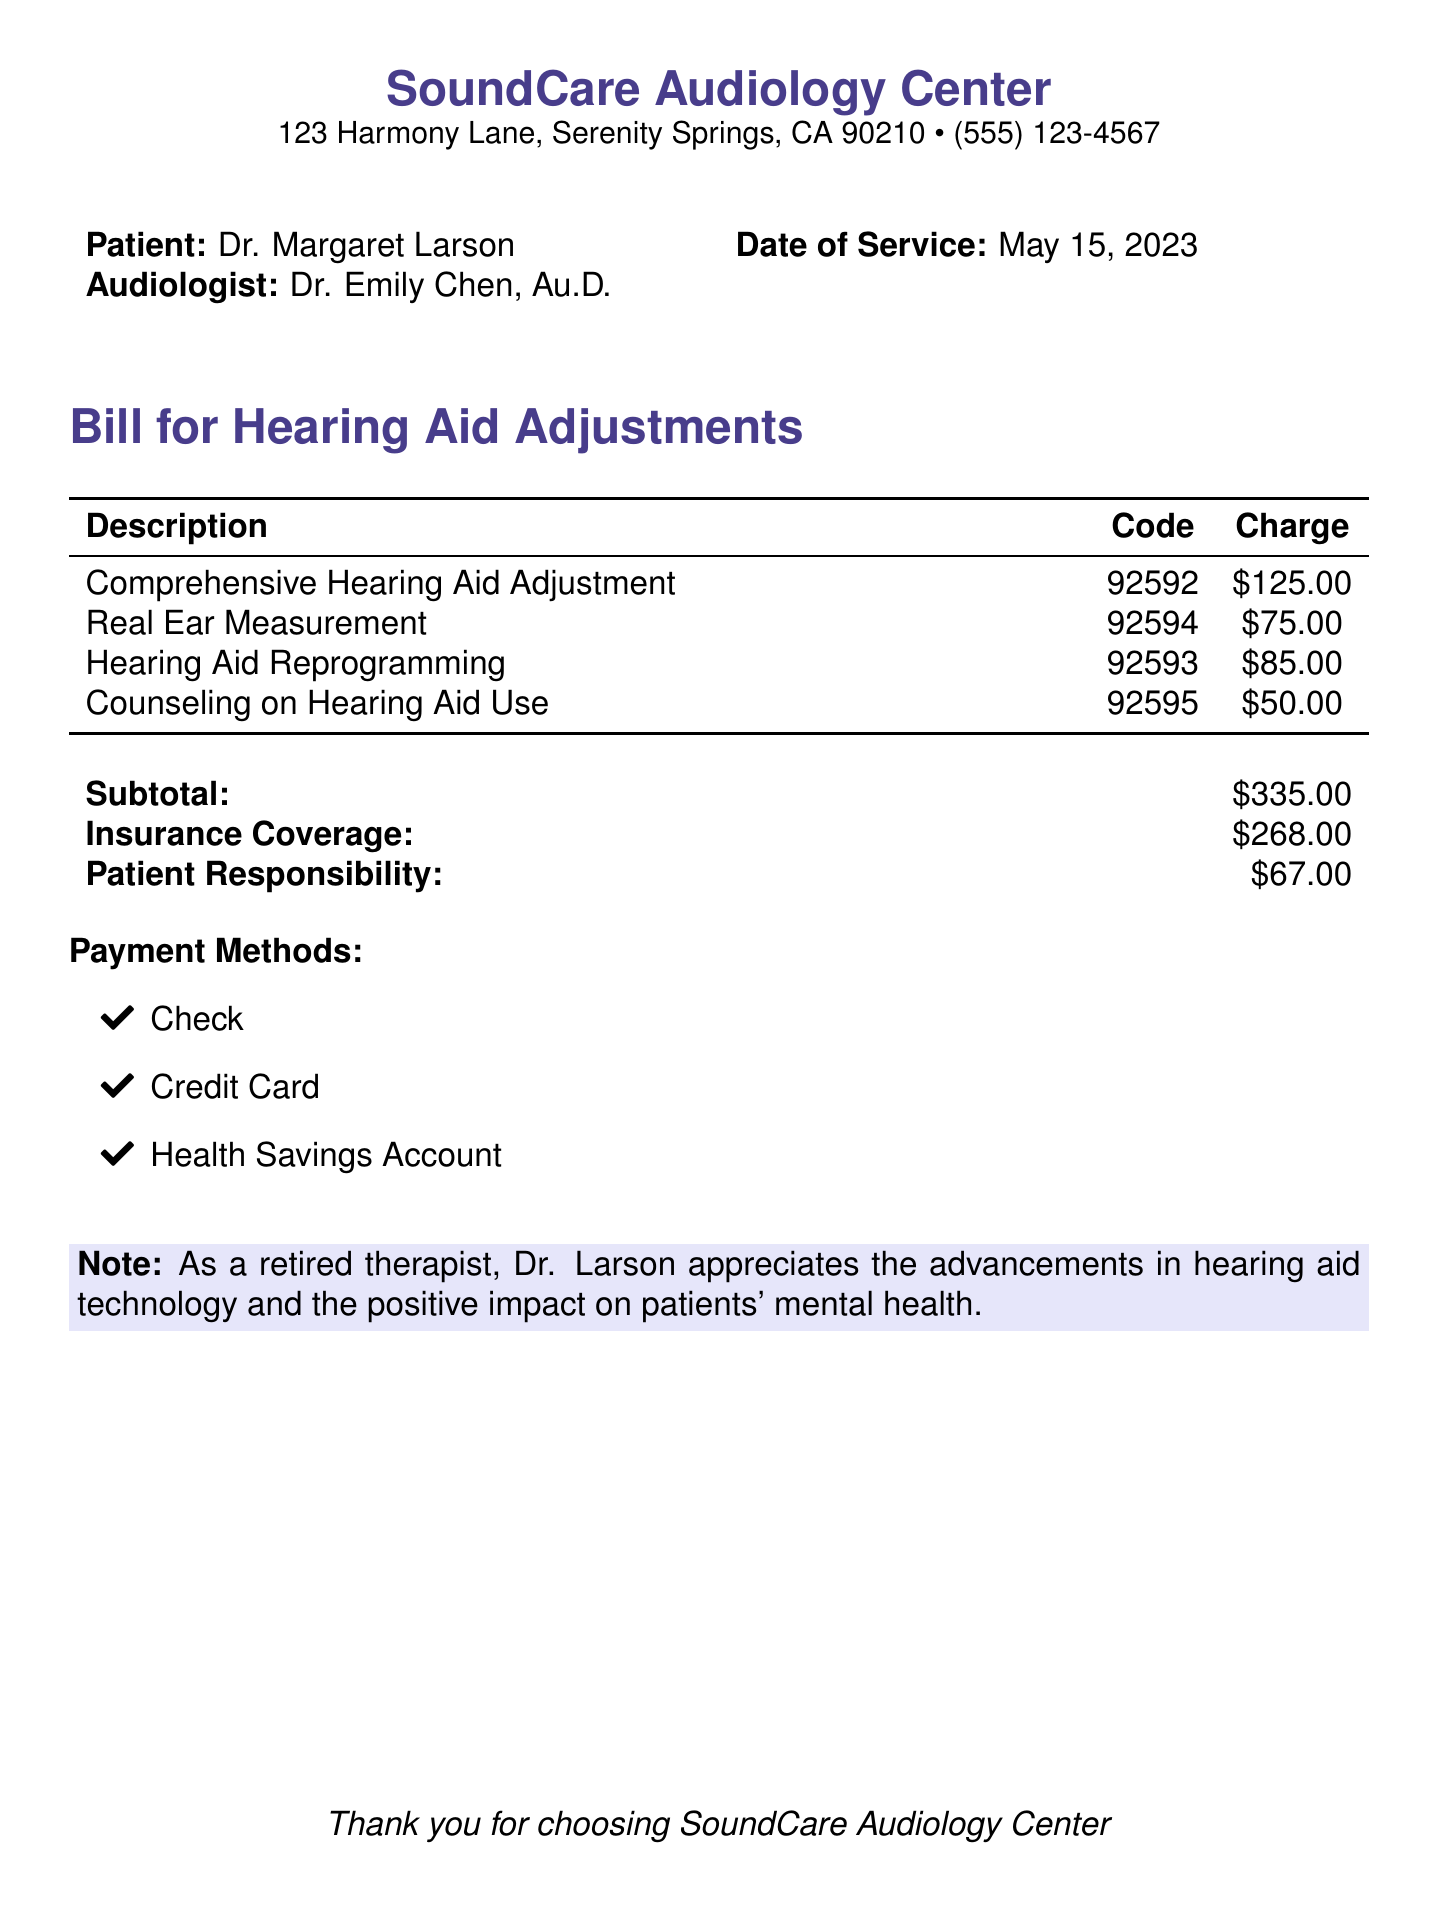What is the date of service? The date of service is explicitly mentioned in the document, which is May 15, 2023.
Answer: May 15, 2023 Who is the audiologist? The audiologist's name is provided in the document, which is Dr. Emily Chen, Au.D.
Answer: Dr. Emily Chen, Au.D What is the charge for Hearing Aid Reprogramming? The charge for Hearing Aid Reprogramming is explicitly listed under the charges in the document, which is $85.00.
Answer: $85.00 What is the subtotal of the services? The subtotal is the total amount before insurance and is clearly detailed in the document, which is $335.00.
Answer: $335.00 How much is the patient responsible for after insurance? The patient responsibility amount is specifically outlined in the document and is $67.00.
Answer: $67.00 What payment methods are accepted? The document lists the payment methods accepted by the audiology center, which include Check, Credit Card, and Health Savings Account.
Answer: Check, Credit Card, Health Savings Account What is the total charge for Counseling on Hearing Aid Use? The specific charge for Counseling on Hearing Aid Use is provided in the document, which is $50.00.
Answer: $50.00 What does the note emphasize about the impact of hearing aid technology? The note in the document emphasizes the positive impact on patients' mental health due to advancements in hearing aid technology.
Answer: Positive impact on patients' mental health 